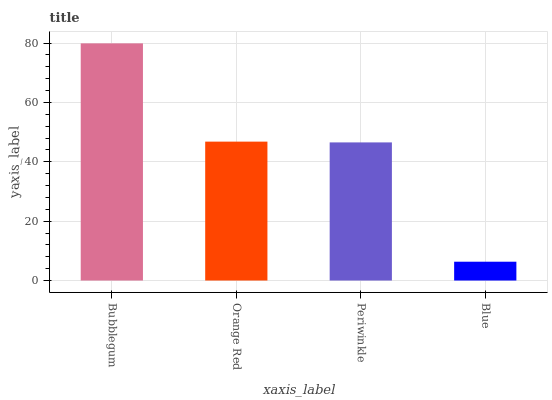Is Blue the minimum?
Answer yes or no. Yes. Is Bubblegum the maximum?
Answer yes or no. Yes. Is Orange Red the minimum?
Answer yes or no. No. Is Orange Red the maximum?
Answer yes or no. No. Is Bubblegum greater than Orange Red?
Answer yes or no. Yes. Is Orange Red less than Bubblegum?
Answer yes or no. Yes. Is Orange Red greater than Bubblegum?
Answer yes or no. No. Is Bubblegum less than Orange Red?
Answer yes or no. No. Is Orange Red the high median?
Answer yes or no. Yes. Is Periwinkle the low median?
Answer yes or no. Yes. Is Periwinkle the high median?
Answer yes or no. No. Is Blue the low median?
Answer yes or no. No. 